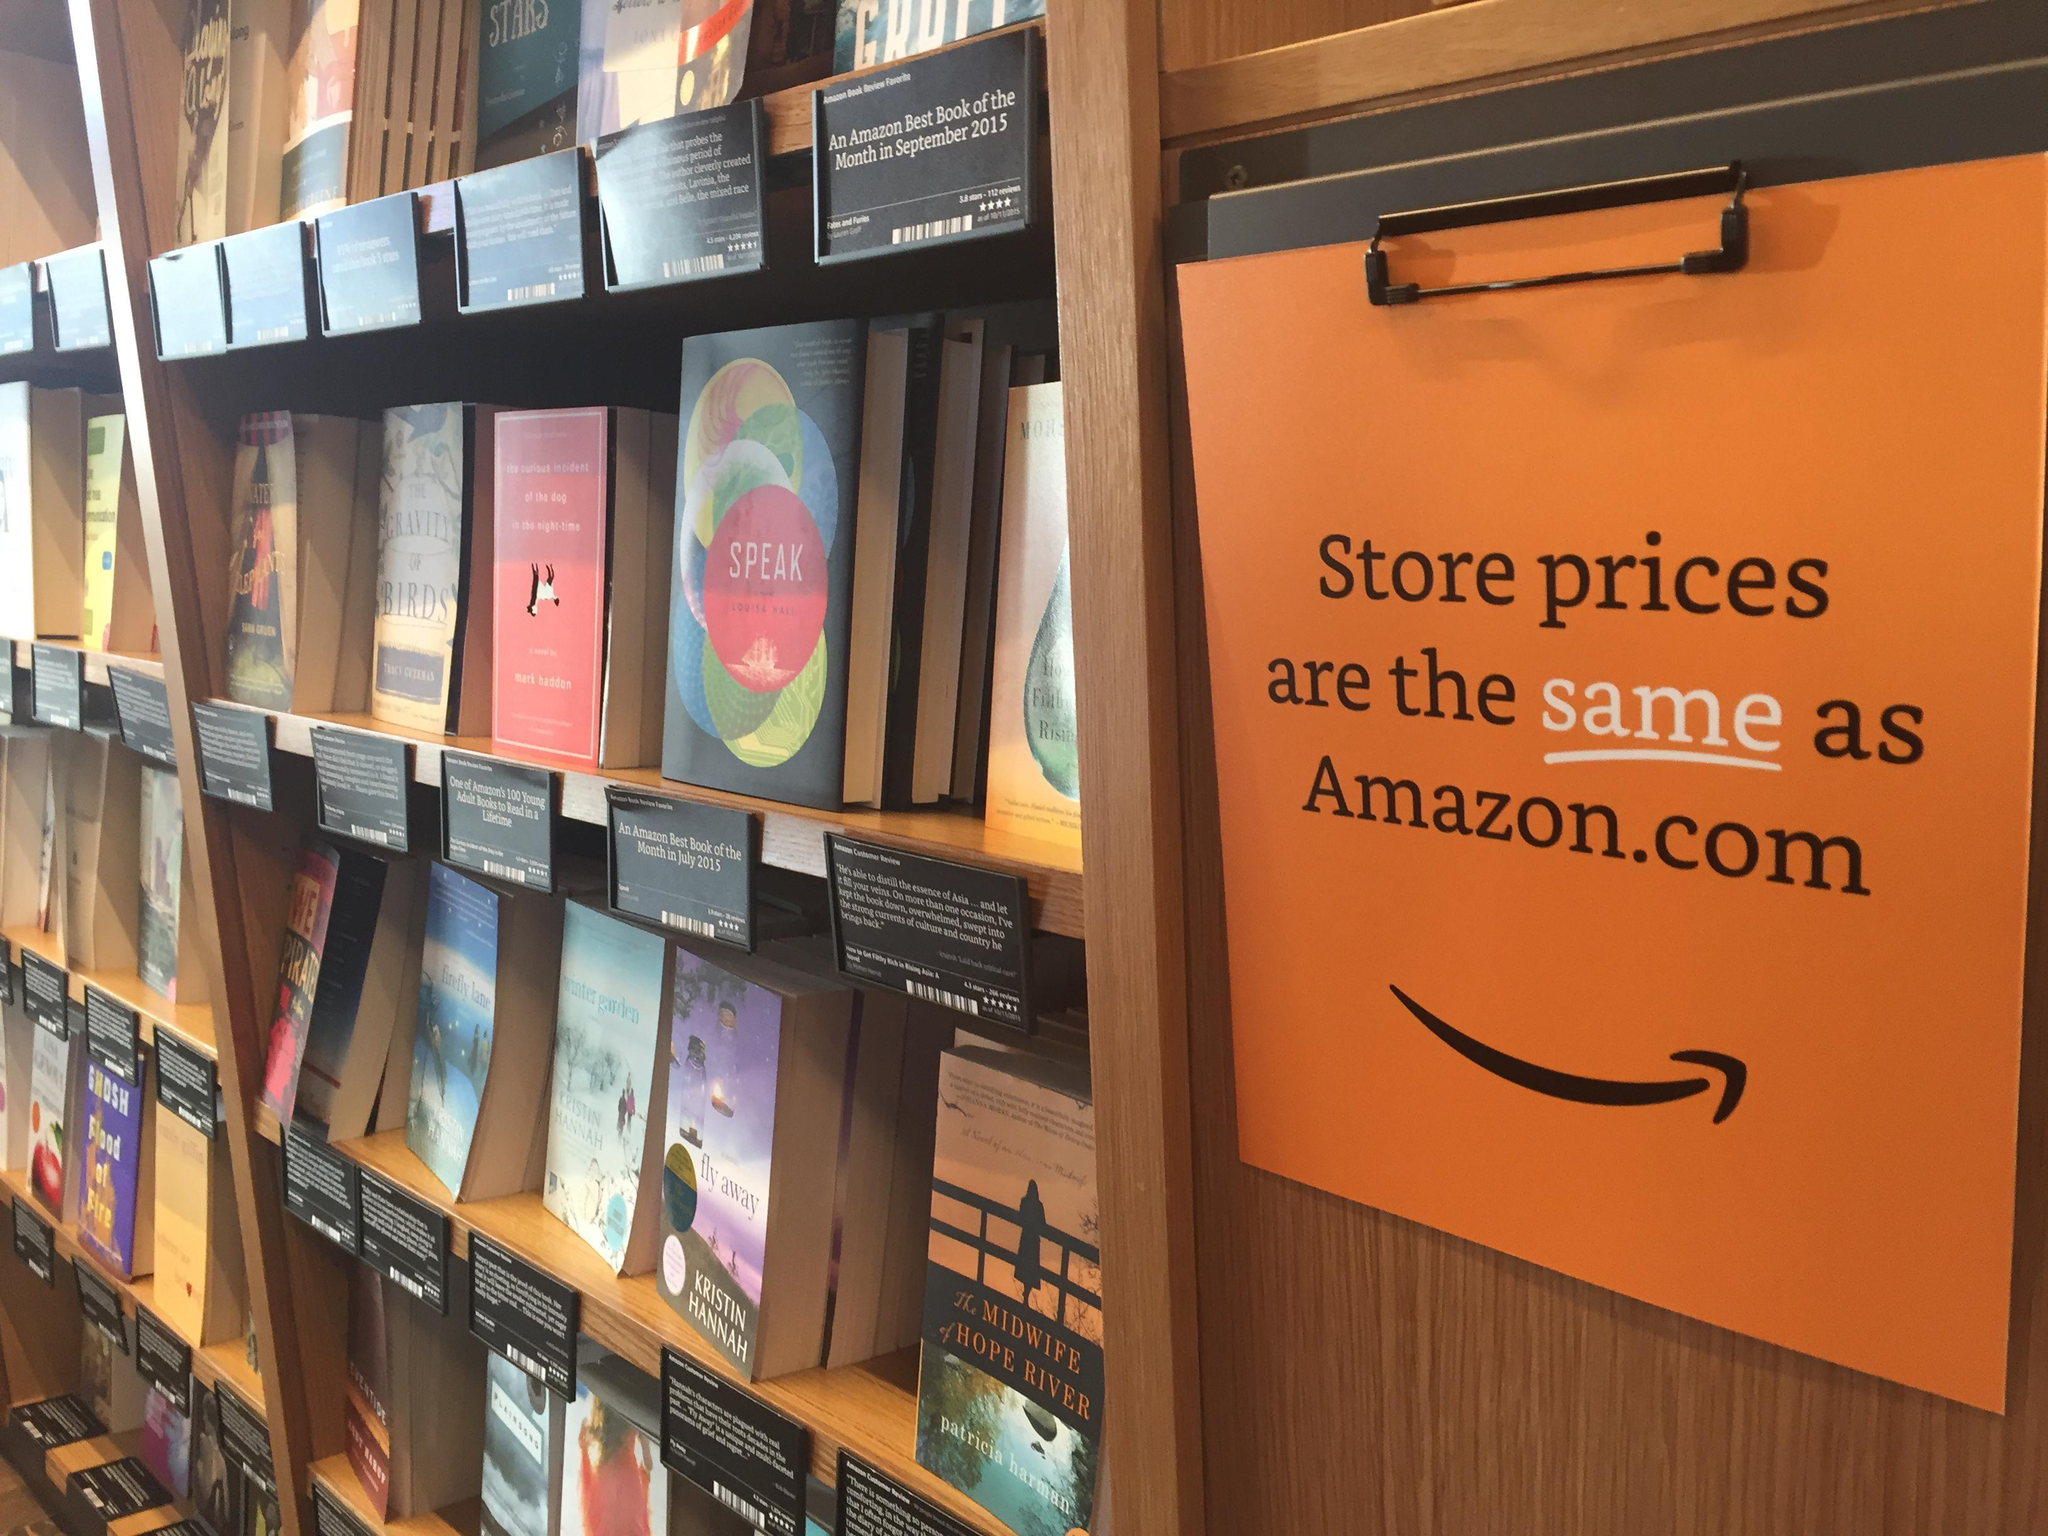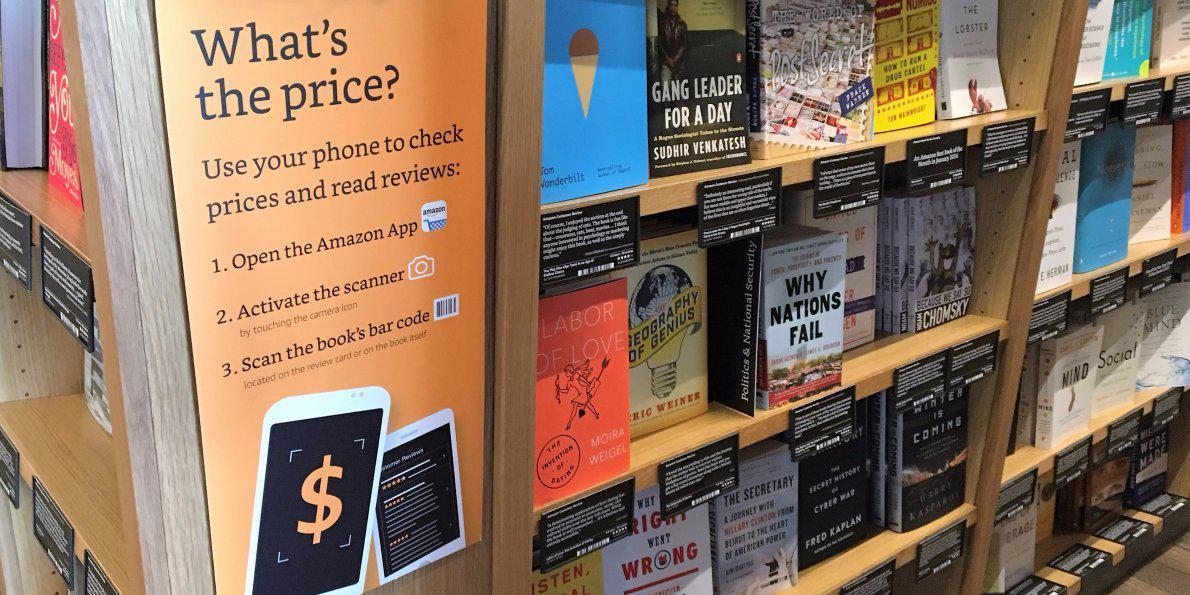The first image is the image on the left, the second image is the image on the right. Assess this claim about the two images: "One image has an orange poster on the bookshelf that states """"What's the price?"""" and the other image shows a poster that mentions Amazon.". Correct or not? Answer yes or no. Yes. 